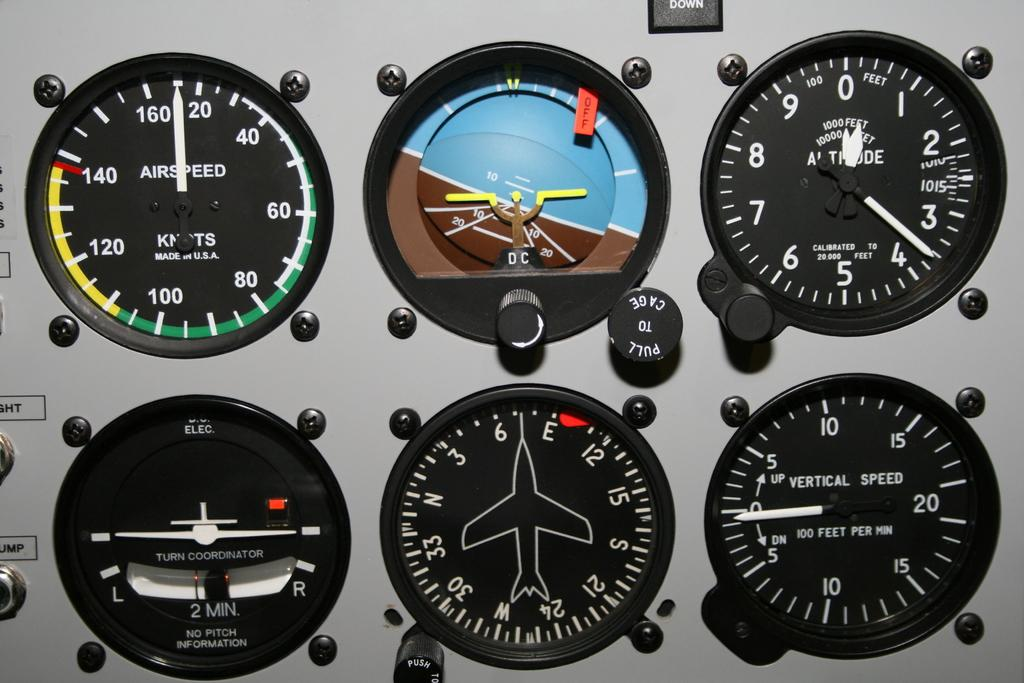<image>
Present a compact description of the photo's key features. 6 different readings, such as air speed, are shown together 